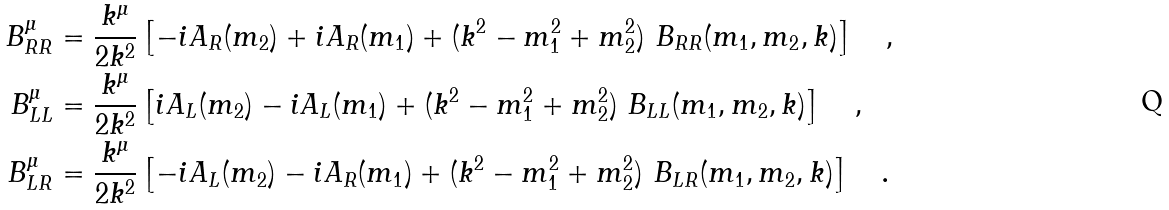<formula> <loc_0><loc_0><loc_500><loc_500>B ^ { \mu } _ { R R } & = \frac { k ^ { \mu } } { 2 k ^ { 2 } } \left [ - i A _ { R } ( m _ { 2 } ) + i A _ { R } ( m _ { 1 } ) + ( k ^ { 2 } - m _ { 1 } ^ { 2 } + m _ { 2 } ^ { 2 } ) \ B _ { R R } ( m _ { 1 } , m _ { 2 } , k ) \right ] \quad , \\ B ^ { \mu } _ { L L } & = \frac { k ^ { \mu } } { 2 k ^ { 2 } } \left [ i A _ { L } ( m _ { 2 } ) - i A _ { L } ( m _ { 1 } ) + ( k ^ { 2 } - m _ { 1 } ^ { 2 } + m _ { 2 } ^ { 2 } ) \ B _ { L L } ( m _ { 1 } , m _ { 2 } , k ) \right ] \quad , \\ B ^ { \mu } _ { L R } & = \frac { k ^ { \mu } } { 2 k ^ { 2 } } \left [ - i A _ { L } ( m _ { 2 } ) - i A _ { R } ( m _ { 1 } ) + ( k ^ { 2 } - m _ { 1 } ^ { 2 } + m _ { 2 } ^ { 2 } ) \ B _ { L R } ( m _ { 1 } , m _ { 2 } , k ) \right ] \quad .</formula> 